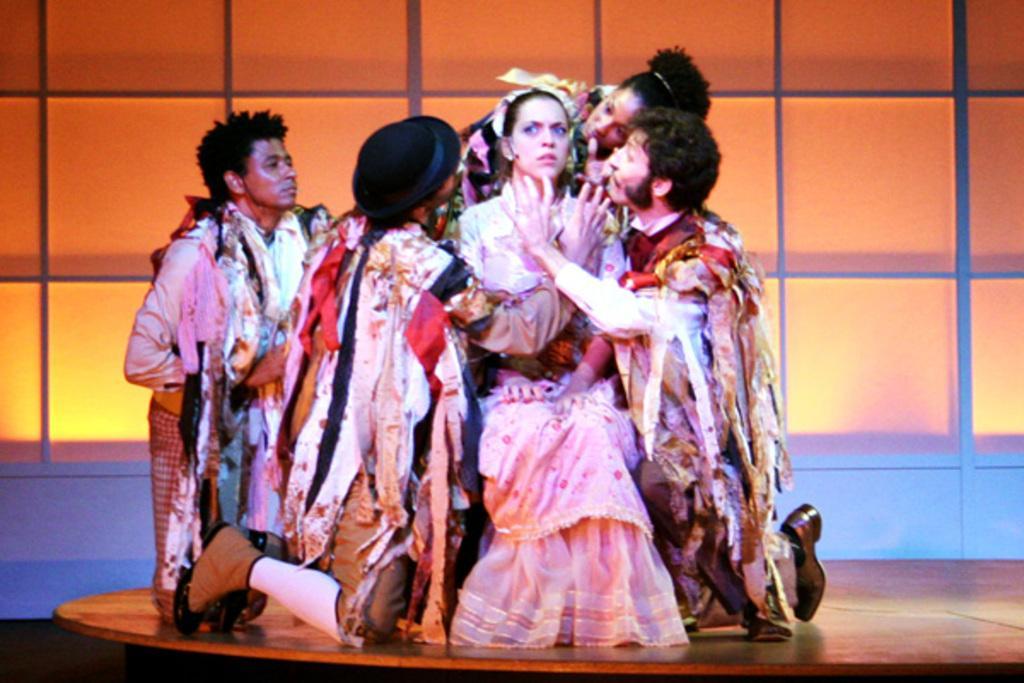Could you give a brief overview of what you see in this image? In this picture we can see a woman is sitting and other people are in the squat position on a wooden object. It looks like the people are in the fancy dresses. Behind the people, it looks like a wall. 